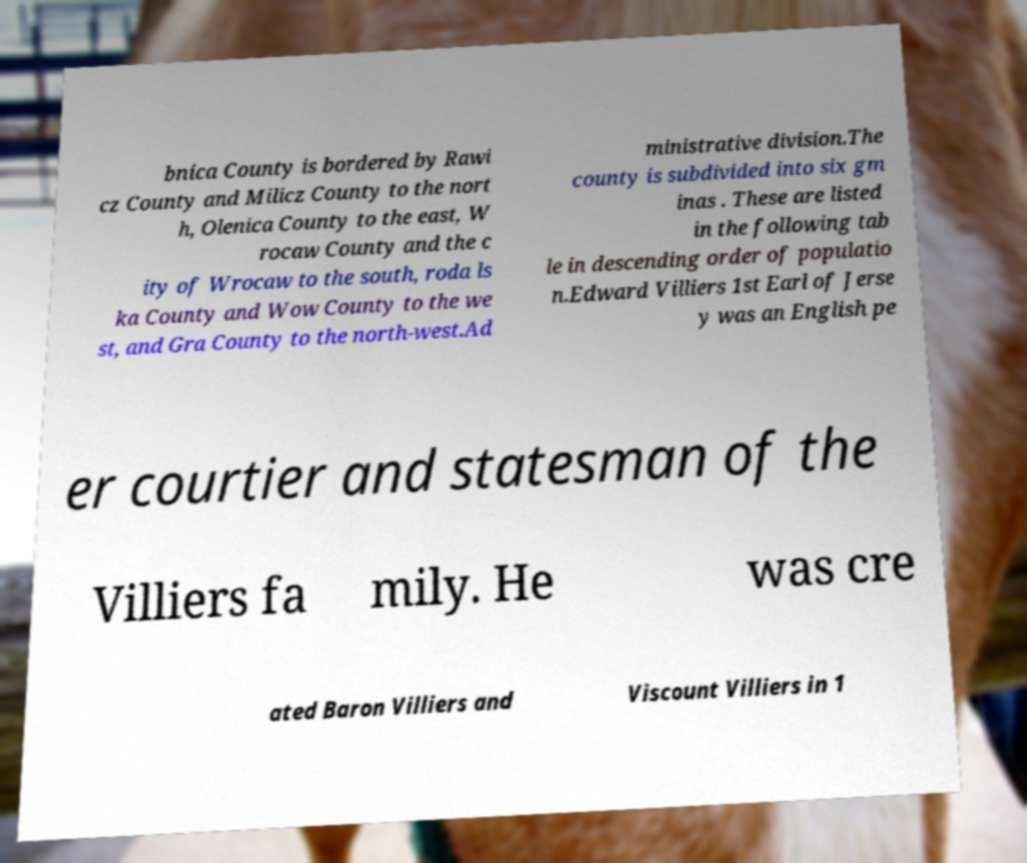Can you accurately transcribe the text from the provided image for me? bnica County is bordered by Rawi cz County and Milicz County to the nort h, Olenica County to the east, W rocaw County and the c ity of Wrocaw to the south, roda ls ka County and Wow County to the we st, and Gra County to the north-west.Ad ministrative division.The county is subdivided into six gm inas . These are listed in the following tab le in descending order of populatio n.Edward Villiers 1st Earl of Jerse y was an English pe er courtier and statesman of the Villiers fa mily. He was cre ated Baron Villiers and Viscount Villiers in 1 